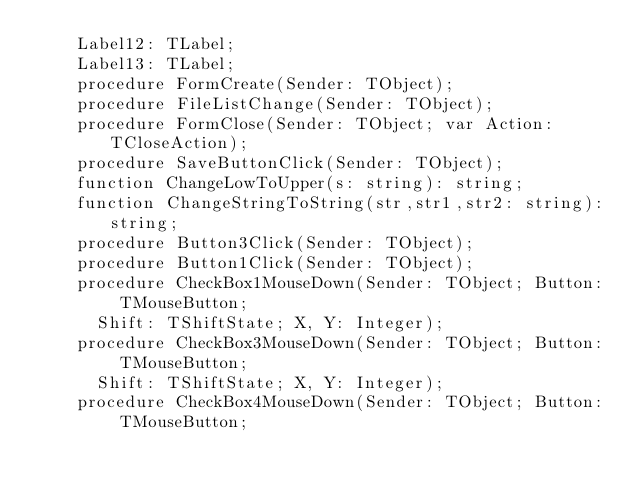Convert code to text. <code><loc_0><loc_0><loc_500><loc_500><_Pascal_>    Label12: TLabel;
    Label13: TLabel;
    procedure FormCreate(Sender: TObject);
    procedure FileListChange(Sender: TObject);
    procedure FormClose(Sender: TObject; var Action: TCloseAction);
    procedure SaveButtonClick(Sender: TObject);
    function ChangeLowToUpper(s: string): string;
    function ChangeStringToString(str,str1,str2: string):string;
    procedure Button3Click(Sender: TObject);
    procedure Button1Click(Sender: TObject);
    procedure CheckBox1MouseDown(Sender: TObject; Button: TMouseButton;
      Shift: TShiftState; X, Y: Integer);
    procedure CheckBox3MouseDown(Sender: TObject; Button: TMouseButton;
      Shift: TShiftState; X, Y: Integer);
    procedure CheckBox4MouseDown(Sender: TObject; Button: TMouseButton;</code> 